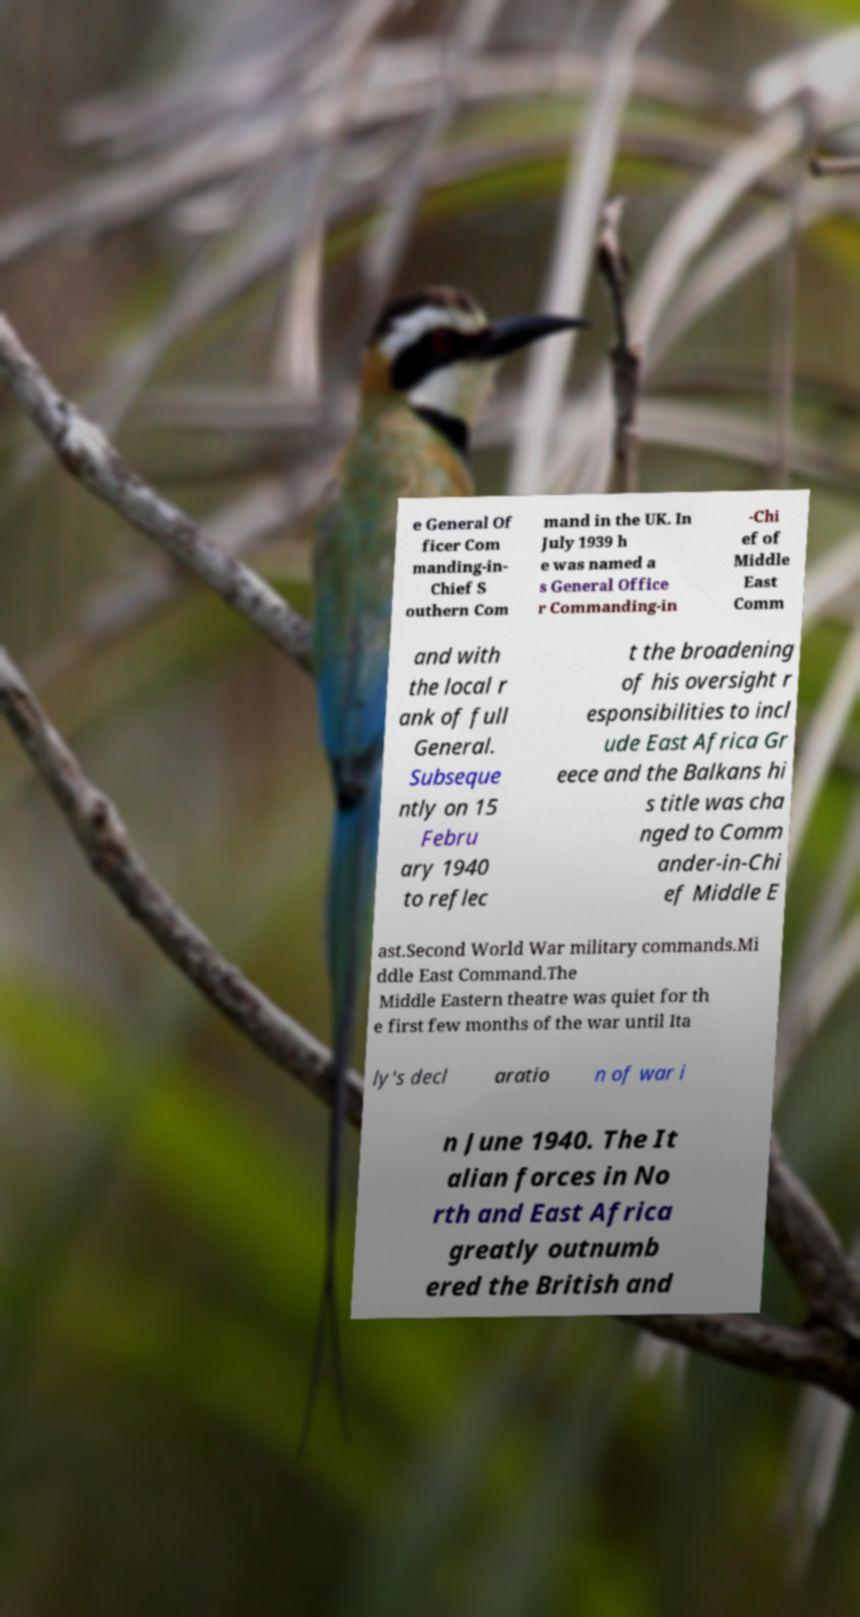For documentation purposes, I need the text within this image transcribed. Could you provide that? e General Of ficer Com manding-in- Chief S outhern Com mand in the UK. In July 1939 h e was named a s General Office r Commanding-in -Chi ef of Middle East Comm and with the local r ank of full General. Subseque ntly on 15 Febru ary 1940 to reflec t the broadening of his oversight r esponsibilities to incl ude East Africa Gr eece and the Balkans hi s title was cha nged to Comm ander-in-Chi ef Middle E ast.Second World War military commands.Mi ddle East Command.The Middle Eastern theatre was quiet for th e first few months of the war until Ita ly's decl aratio n of war i n June 1940. The It alian forces in No rth and East Africa greatly outnumb ered the British and 